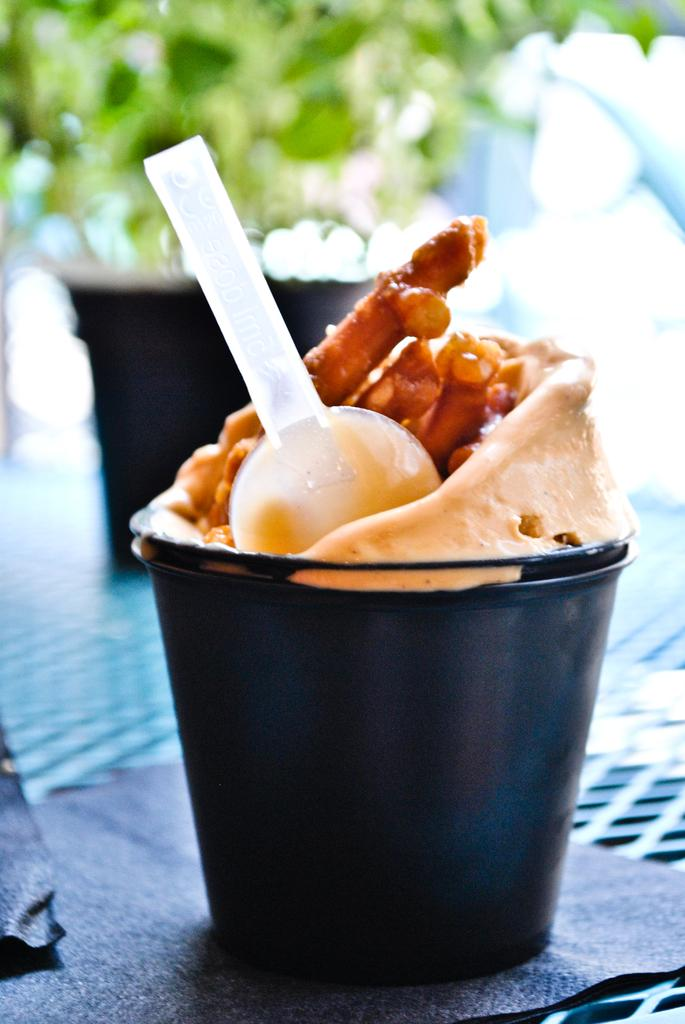What is in the cup that is visible in the image? There is a food item in a cup in the image. What utensil is present in the image? There is a spoon in the image. Where are the food item and spoon located? The food item and spoon are on a table. Can you describe the background of the image? The background of the image is blurred. What type of sand can be seen in the image? There is no sand present in the image. What is being served for dinner in the image? The image does not depict a dinner scene, so it cannot be determined what is being served. 